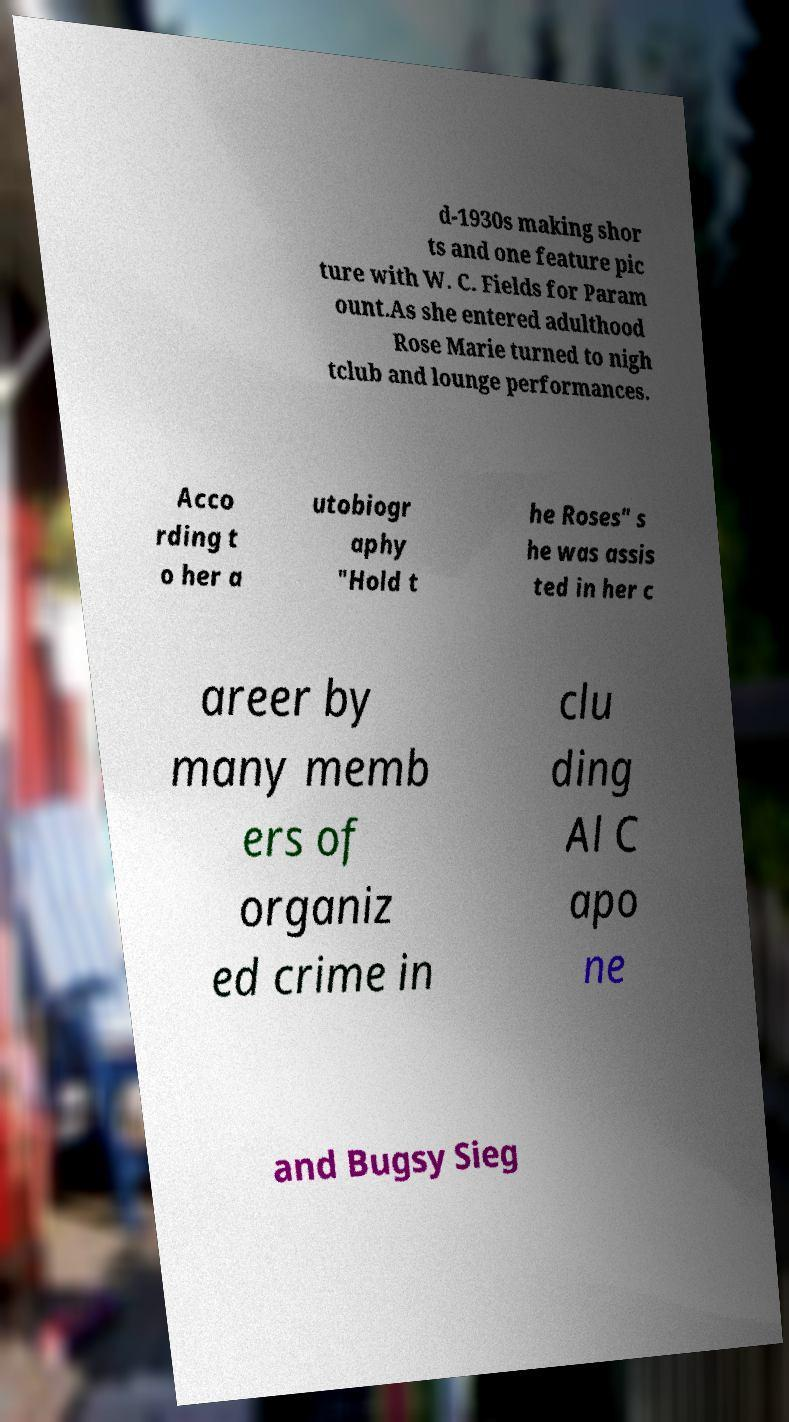Can you accurately transcribe the text from the provided image for me? d-1930s making shor ts and one feature pic ture with W. C. Fields for Param ount.As she entered adulthood Rose Marie turned to nigh tclub and lounge performances. Acco rding t o her a utobiogr aphy "Hold t he Roses" s he was assis ted in her c areer by many memb ers of organiz ed crime in clu ding Al C apo ne and Bugsy Sieg 